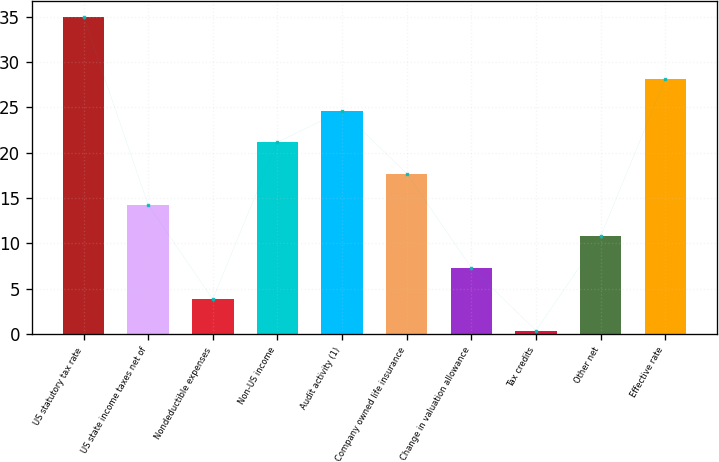<chart> <loc_0><loc_0><loc_500><loc_500><bar_chart><fcel>US statutory tax rate<fcel>US state income taxes net of<fcel>Nondeductible expenses<fcel>Non-US income<fcel>Audit activity (1)<fcel>Company owned life insurance<fcel>Change in valuation allowance<fcel>Tax credits<fcel>Other net<fcel>Effective rate<nl><fcel>35<fcel>14.24<fcel>3.86<fcel>21.16<fcel>24.62<fcel>17.7<fcel>7.32<fcel>0.4<fcel>10.78<fcel>28.08<nl></chart> 